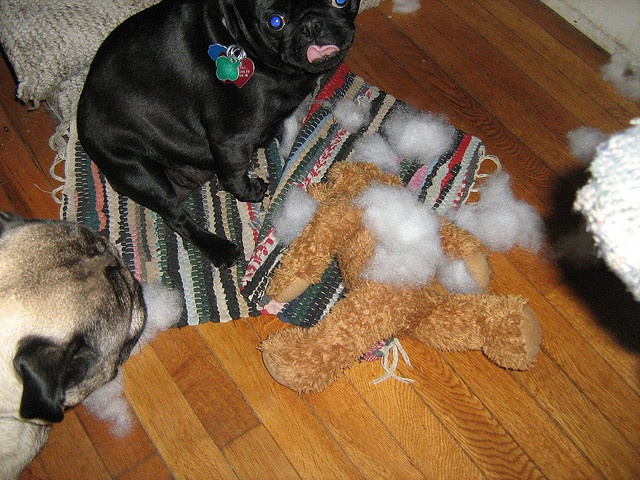Describe the objects in this image and their specific colors. I can see dog in black, gray, and maroon tones, teddy bear in black, brown, and tan tones, and dog in black, gray, tan, and darkgray tones in this image. 